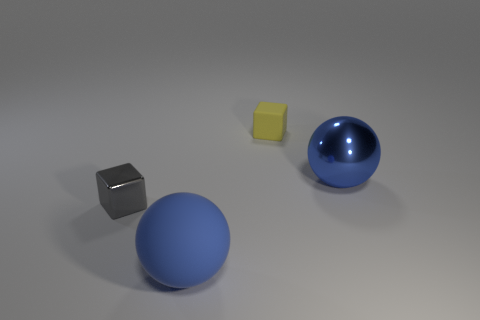There is a rubber thing that is the same shape as the small metal thing; what color is it?
Keep it short and to the point. Yellow. There is a object that is the same color as the big rubber sphere; what shape is it?
Your answer should be compact. Sphere. Does the shiny object behind the gray thing have the same shape as the blue rubber object that is in front of the small yellow matte cube?
Offer a terse response. Yes. The other object that is the same color as the large shiny object is what size?
Offer a very short reply. Large. What number of other objects are the same size as the yellow rubber thing?
Offer a very short reply. 1. There is a shiny ball; does it have the same color as the ball that is in front of the big shiny ball?
Ensure brevity in your answer.  Yes. Are there fewer big rubber objects behind the yellow cube than large objects right of the large blue metal object?
Make the answer very short. No. There is a thing that is right of the gray shiny block and in front of the large blue metal sphere; what is its color?
Offer a very short reply. Blue. There is a yellow rubber object; is its size the same as the blue ball right of the rubber sphere?
Make the answer very short. No. What is the shape of the tiny thing on the right side of the blue matte object?
Offer a very short reply. Cube. 